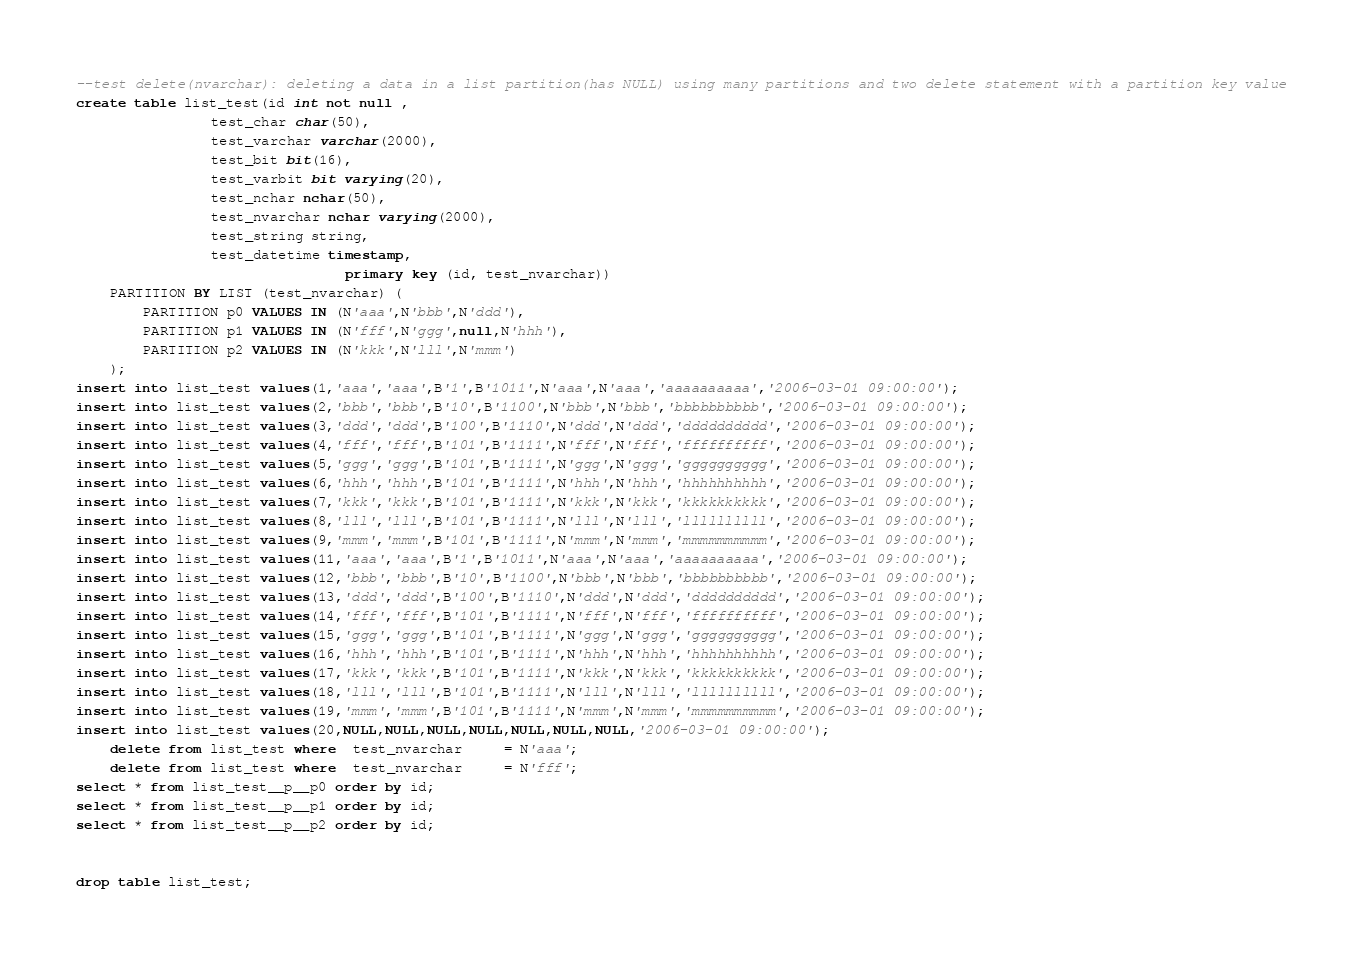Convert code to text. <code><loc_0><loc_0><loc_500><loc_500><_SQL_>--test delete(nvarchar): deleting a data in a list partition(has NULL) using many partitions and two delete statement with a partition key value
create table list_test(id int not null ,
				test_char char(50),
				test_varchar varchar(2000),
				test_bit bit(16),
				test_varbit bit varying(20),
				test_nchar nchar(50),
				test_nvarchar nchar varying(2000),
				test_string string,
				test_datetime timestamp,
                                primary key (id, test_nvarchar))
	PARTITION BY LIST (test_nvarchar) (
	    PARTITION p0 VALUES IN (N'aaa',N'bbb',N'ddd'),
	    PARTITION p1 VALUES IN (N'fff',N'ggg',null,N'hhh'),
	    PARTITION p2 VALUES IN (N'kkk',N'lll',N'mmm')
	);
insert into list_test values(1,'aaa','aaa',B'1',B'1011',N'aaa',N'aaa','aaaaaaaaaa','2006-03-01 09:00:00');   
insert into list_test values(2,'bbb','bbb',B'10',B'1100',N'bbb',N'bbb','bbbbbbbbbb','2006-03-01 09:00:00');  
insert into list_test values(3,'ddd','ddd',B'100',B'1110',N'ddd',N'ddd','dddddddddd','2006-03-01 09:00:00'); 
insert into list_test values(4,'fff','fff',B'101',B'1111',N'fff',N'fff','ffffffffff','2006-03-01 09:00:00'); 
insert into list_test values(5,'ggg','ggg',B'101',B'1111',N'ggg',N'ggg','gggggggggg','2006-03-01 09:00:00'); 
insert into list_test values(6,'hhh','hhh',B'101',B'1111',N'hhh',N'hhh','hhhhhhhhhh','2006-03-01 09:00:00'); 
insert into list_test values(7,'kkk','kkk',B'101',B'1111',N'kkk',N'kkk','kkkkkkkkkk','2006-03-01 09:00:00'); 
insert into list_test values(8,'lll','lll',B'101',B'1111',N'lll',N'lll','llllllllll','2006-03-01 09:00:00'); 
insert into list_test values(9,'mmm','mmm',B'101',B'1111',N'mmm',N'mmm','mmmmmmmmmm','2006-03-01 09:00:00'); 
insert into list_test values(11,'aaa','aaa',B'1',B'1011',N'aaa',N'aaa','aaaaaaaaaa','2006-03-01 09:00:00');  
insert into list_test values(12,'bbb','bbb',B'10',B'1100',N'bbb',N'bbb','bbbbbbbbbb','2006-03-01 09:00:00'); 
insert into list_test values(13,'ddd','ddd',B'100',B'1110',N'ddd',N'ddd','dddddddddd','2006-03-01 09:00:00');
insert into list_test values(14,'fff','fff',B'101',B'1111',N'fff',N'fff','ffffffffff','2006-03-01 09:00:00');
insert into list_test values(15,'ggg','ggg',B'101',B'1111',N'ggg',N'ggg','gggggggggg','2006-03-01 09:00:00');
insert into list_test values(16,'hhh','hhh',B'101',B'1111',N'hhh',N'hhh','hhhhhhhhhh','2006-03-01 09:00:00');
insert into list_test values(17,'kkk','kkk',B'101',B'1111',N'kkk',N'kkk','kkkkkkkkkk','2006-03-01 09:00:00');
insert into list_test values(18,'lll','lll',B'101',B'1111',N'lll',N'lll','llllllllll','2006-03-01 09:00:00');
insert into list_test values(19,'mmm','mmm',B'101',B'1111',N'mmm',N'mmm','mmmmmmmmmm','2006-03-01 09:00:00');
insert into list_test values(20,NULL,NULL,NULL,NULL,NULL,NULL,NULL,'2006-03-01 09:00:00');
	delete from list_test where  test_nvarchar     = N'aaa';
	delete from list_test where  test_nvarchar     = N'fff';
select * from list_test__p__p0 order by id;
select * from list_test__p__p1 order by id;
select * from list_test__p__p2 order by id;


drop table list_test;
</code> 